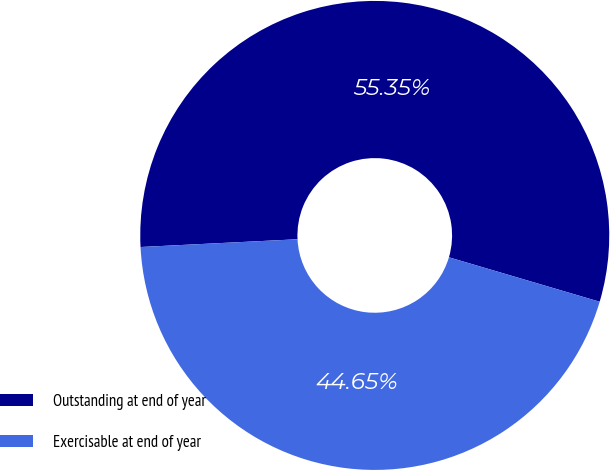<chart> <loc_0><loc_0><loc_500><loc_500><pie_chart><fcel>Outstanding at end of year<fcel>Exercisable at end of year<nl><fcel>55.35%<fcel>44.65%<nl></chart> 